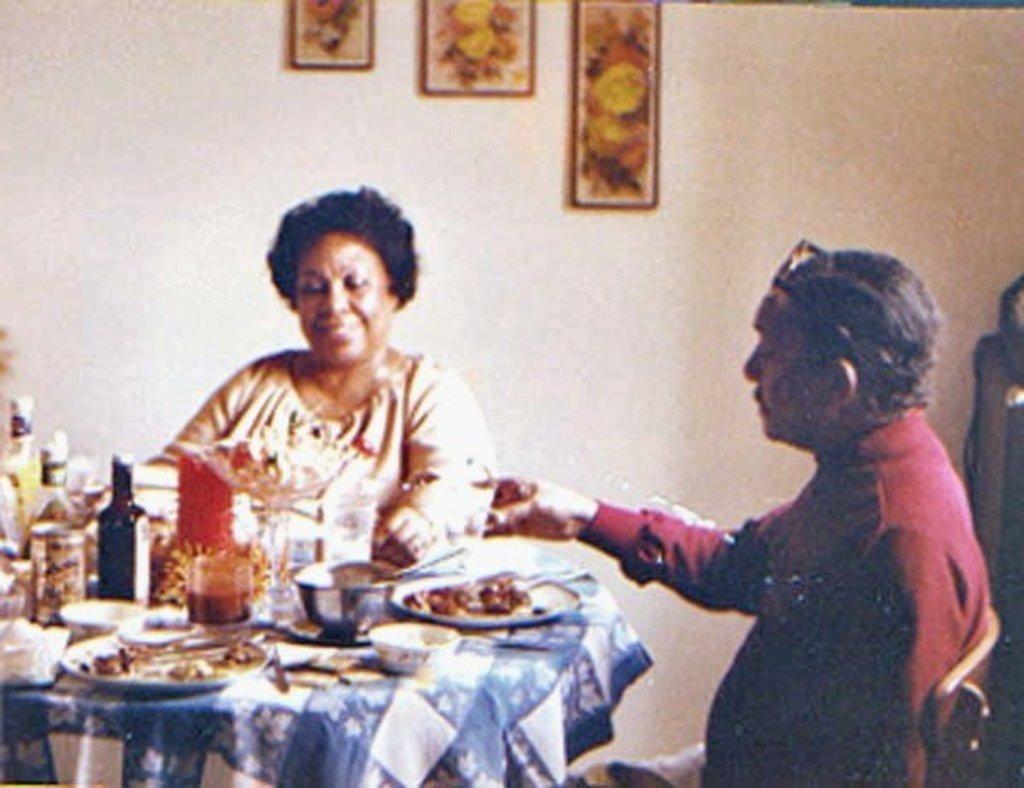What is hanging objects can be seen on the wall in the image? There are frames on the wall in the image. How many people are present in the image? There is a man and a woman in the image. What is on the table in the image? There is a cloth on a table in the image. What type of containers are visible in the image? There are bottles in the image. What is being served or consumed in the image? There is food in the image. What type of dishware is present in the image? There are plates and a bowl in the image. Are there any other objects present in the image? Yes, there are additional objects in the image. How many lizards are crawling on the food in the image? There are no lizards present in the image. What type of war is being depicted in the image? There is no depiction of war in the image. What color are the cherries on the plates in the image? There are no cherries present in the image. 